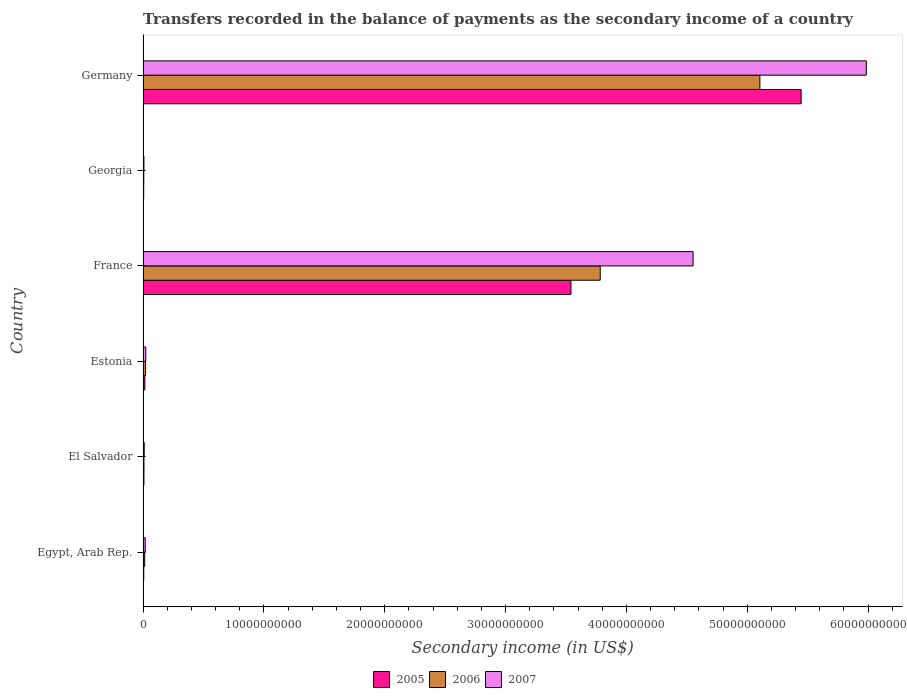How many groups of bars are there?
Offer a very short reply. 6. Are the number of bars per tick equal to the number of legend labels?
Your answer should be very brief. Yes. Are the number of bars on each tick of the Y-axis equal?
Keep it short and to the point. Yes. How many bars are there on the 5th tick from the top?
Provide a succinct answer. 3. What is the label of the 5th group of bars from the top?
Provide a succinct answer. El Salvador. In how many cases, is the number of bars for a given country not equal to the number of legend labels?
Your response must be concise. 0. What is the secondary income of in 2005 in Georgia?
Offer a terse response. 5.19e+07. Across all countries, what is the maximum secondary income of in 2006?
Your response must be concise. 5.10e+1. Across all countries, what is the minimum secondary income of in 2005?
Provide a succinct answer. 5.19e+07. In which country was the secondary income of in 2007 minimum?
Give a very brief answer. Georgia. What is the total secondary income of in 2007 in the graph?
Keep it short and to the point. 1.06e+11. What is the difference between the secondary income of in 2005 in El Salvador and that in France?
Offer a very short reply. -3.53e+1. What is the difference between the secondary income of in 2005 in El Salvador and the secondary income of in 2007 in Germany?
Ensure brevity in your answer.  -5.98e+1. What is the average secondary income of in 2006 per country?
Make the answer very short. 1.49e+1. What is the difference between the secondary income of in 2005 and secondary income of in 2006 in Egypt, Arab Rep.?
Provide a succinct answer. -7.78e+07. What is the ratio of the secondary income of in 2005 in El Salvador to that in Estonia?
Your answer should be very brief. 0.49. Is the secondary income of in 2007 in El Salvador less than that in Germany?
Your answer should be very brief. Yes. Is the difference between the secondary income of in 2005 in Egypt, Arab Rep. and El Salvador greater than the difference between the secondary income of in 2006 in Egypt, Arab Rep. and El Salvador?
Provide a short and direct response. No. What is the difference between the highest and the second highest secondary income of in 2006?
Your response must be concise. 1.32e+1. What is the difference between the highest and the lowest secondary income of in 2005?
Provide a short and direct response. 5.44e+1. In how many countries, is the secondary income of in 2005 greater than the average secondary income of in 2005 taken over all countries?
Your response must be concise. 2. Is the sum of the secondary income of in 2007 in Estonia and France greater than the maximum secondary income of in 2005 across all countries?
Provide a succinct answer. No. What does the 2nd bar from the bottom in France represents?
Offer a terse response. 2006. Are all the bars in the graph horizontal?
Offer a terse response. Yes. What is the difference between two consecutive major ticks on the X-axis?
Offer a terse response. 1.00e+1. Does the graph contain any zero values?
Ensure brevity in your answer.  No. Where does the legend appear in the graph?
Your answer should be very brief. Bottom center. What is the title of the graph?
Give a very brief answer. Transfers recorded in the balance of payments as the secondary income of a country. Does "1970" appear as one of the legend labels in the graph?
Ensure brevity in your answer.  No. What is the label or title of the X-axis?
Provide a short and direct response. Secondary income (in US$). What is the label or title of the Y-axis?
Your answer should be compact. Country. What is the Secondary income (in US$) of 2005 in Egypt, Arab Rep.?
Offer a very short reply. 5.73e+07. What is the Secondary income (in US$) in 2006 in Egypt, Arab Rep.?
Make the answer very short. 1.35e+08. What is the Secondary income (in US$) in 2007 in Egypt, Arab Rep.?
Offer a very short reply. 1.80e+08. What is the Secondary income (in US$) in 2005 in El Salvador?
Give a very brief answer. 7.14e+07. What is the Secondary income (in US$) in 2006 in El Salvador?
Keep it short and to the point. 7.68e+07. What is the Secondary income (in US$) of 2007 in El Salvador?
Ensure brevity in your answer.  9.57e+07. What is the Secondary income (in US$) of 2005 in Estonia?
Make the answer very short. 1.46e+08. What is the Secondary income (in US$) in 2006 in Estonia?
Give a very brief answer. 2.08e+08. What is the Secondary income (in US$) of 2007 in Estonia?
Give a very brief answer. 2.27e+08. What is the Secondary income (in US$) of 2005 in France?
Ensure brevity in your answer.  3.54e+1. What is the Secondary income (in US$) of 2006 in France?
Provide a succinct answer. 3.78e+1. What is the Secondary income (in US$) in 2007 in France?
Your answer should be very brief. 4.55e+1. What is the Secondary income (in US$) of 2005 in Georgia?
Give a very brief answer. 5.19e+07. What is the Secondary income (in US$) of 2006 in Georgia?
Provide a succinct answer. 5.94e+07. What is the Secondary income (in US$) of 2007 in Georgia?
Offer a terse response. 7.21e+07. What is the Secondary income (in US$) in 2005 in Germany?
Keep it short and to the point. 5.45e+1. What is the Secondary income (in US$) in 2006 in Germany?
Ensure brevity in your answer.  5.10e+1. What is the Secondary income (in US$) in 2007 in Germany?
Provide a succinct answer. 5.99e+1. Across all countries, what is the maximum Secondary income (in US$) in 2005?
Your answer should be very brief. 5.45e+1. Across all countries, what is the maximum Secondary income (in US$) in 2006?
Make the answer very short. 5.10e+1. Across all countries, what is the maximum Secondary income (in US$) in 2007?
Make the answer very short. 5.99e+1. Across all countries, what is the minimum Secondary income (in US$) in 2005?
Keep it short and to the point. 5.19e+07. Across all countries, what is the minimum Secondary income (in US$) in 2006?
Keep it short and to the point. 5.94e+07. Across all countries, what is the minimum Secondary income (in US$) of 2007?
Provide a succinct answer. 7.21e+07. What is the total Secondary income (in US$) in 2005 in the graph?
Keep it short and to the point. 9.02e+1. What is the total Secondary income (in US$) in 2006 in the graph?
Provide a short and direct response. 8.94e+1. What is the total Secondary income (in US$) in 2007 in the graph?
Provide a succinct answer. 1.06e+11. What is the difference between the Secondary income (in US$) in 2005 in Egypt, Arab Rep. and that in El Salvador?
Make the answer very short. -1.41e+07. What is the difference between the Secondary income (in US$) in 2006 in Egypt, Arab Rep. and that in El Salvador?
Ensure brevity in your answer.  5.83e+07. What is the difference between the Secondary income (in US$) in 2007 in Egypt, Arab Rep. and that in El Salvador?
Your answer should be compact. 8.42e+07. What is the difference between the Secondary income (in US$) of 2005 in Egypt, Arab Rep. and that in Estonia?
Give a very brief answer. -8.83e+07. What is the difference between the Secondary income (in US$) of 2006 in Egypt, Arab Rep. and that in Estonia?
Ensure brevity in your answer.  -7.26e+07. What is the difference between the Secondary income (in US$) of 2007 in Egypt, Arab Rep. and that in Estonia?
Make the answer very short. -4.70e+07. What is the difference between the Secondary income (in US$) in 2005 in Egypt, Arab Rep. and that in France?
Offer a terse response. -3.54e+1. What is the difference between the Secondary income (in US$) in 2006 in Egypt, Arab Rep. and that in France?
Your answer should be compact. -3.77e+1. What is the difference between the Secondary income (in US$) of 2007 in Egypt, Arab Rep. and that in France?
Offer a terse response. -4.53e+1. What is the difference between the Secondary income (in US$) of 2005 in Egypt, Arab Rep. and that in Georgia?
Your answer should be very brief. 5.35e+06. What is the difference between the Secondary income (in US$) of 2006 in Egypt, Arab Rep. and that in Georgia?
Your response must be concise. 7.57e+07. What is the difference between the Secondary income (in US$) in 2007 in Egypt, Arab Rep. and that in Georgia?
Your response must be concise. 1.08e+08. What is the difference between the Secondary income (in US$) of 2005 in Egypt, Arab Rep. and that in Germany?
Offer a very short reply. -5.44e+1. What is the difference between the Secondary income (in US$) of 2006 in Egypt, Arab Rep. and that in Germany?
Ensure brevity in your answer.  -5.09e+1. What is the difference between the Secondary income (in US$) in 2007 in Egypt, Arab Rep. and that in Germany?
Ensure brevity in your answer.  -5.97e+1. What is the difference between the Secondary income (in US$) of 2005 in El Salvador and that in Estonia?
Your answer should be compact. -7.42e+07. What is the difference between the Secondary income (in US$) in 2006 in El Salvador and that in Estonia?
Your answer should be very brief. -1.31e+08. What is the difference between the Secondary income (in US$) in 2007 in El Salvador and that in Estonia?
Your answer should be very brief. -1.31e+08. What is the difference between the Secondary income (in US$) in 2005 in El Salvador and that in France?
Give a very brief answer. -3.53e+1. What is the difference between the Secondary income (in US$) in 2006 in El Salvador and that in France?
Your response must be concise. -3.78e+1. What is the difference between the Secondary income (in US$) in 2007 in El Salvador and that in France?
Your answer should be very brief. -4.54e+1. What is the difference between the Secondary income (in US$) of 2005 in El Salvador and that in Georgia?
Keep it short and to the point. 1.95e+07. What is the difference between the Secondary income (in US$) of 2006 in El Salvador and that in Georgia?
Ensure brevity in your answer.  1.74e+07. What is the difference between the Secondary income (in US$) in 2007 in El Salvador and that in Georgia?
Your answer should be very brief. 2.37e+07. What is the difference between the Secondary income (in US$) of 2005 in El Salvador and that in Germany?
Offer a terse response. -5.44e+1. What is the difference between the Secondary income (in US$) in 2006 in El Salvador and that in Germany?
Offer a terse response. -5.10e+1. What is the difference between the Secondary income (in US$) of 2007 in El Salvador and that in Germany?
Offer a very short reply. -5.98e+1. What is the difference between the Secondary income (in US$) in 2005 in Estonia and that in France?
Your answer should be compact. -3.53e+1. What is the difference between the Secondary income (in US$) in 2006 in Estonia and that in France?
Make the answer very short. -3.76e+1. What is the difference between the Secondary income (in US$) of 2007 in Estonia and that in France?
Your response must be concise. -4.53e+1. What is the difference between the Secondary income (in US$) of 2005 in Estonia and that in Georgia?
Give a very brief answer. 9.36e+07. What is the difference between the Secondary income (in US$) of 2006 in Estonia and that in Georgia?
Your answer should be compact. 1.48e+08. What is the difference between the Secondary income (in US$) of 2007 in Estonia and that in Georgia?
Provide a short and direct response. 1.55e+08. What is the difference between the Secondary income (in US$) in 2005 in Estonia and that in Germany?
Offer a terse response. -5.43e+1. What is the difference between the Secondary income (in US$) of 2006 in Estonia and that in Germany?
Keep it short and to the point. -5.08e+1. What is the difference between the Secondary income (in US$) in 2007 in Estonia and that in Germany?
Make the answer very short. -5.96e+1. What is the difference between the Secondary income (in US$) of 2005 in France and that in Georgia?
Keep it short and to the point. 3.54e+1. What is the difference between the Secondary income (in US$) of 2006 in France and that in Georgia?
Your answer should be compact. 3.78e+1. What is the difference between the Secondary income (in US$) in 2007 in France and that in Georgia?
Your response must be concise. 4.54e+1. What is the difference between the Secondary income (in US$) of 2005 in France and that in Germany?
Make the answer very short. -1.91e+1. What is the difference between the Secondary income (in US$) in 2006 in France and that in Germany?
Ensure brevity in your answer.  -1.32e+1. What is the difference between the Secondary income (in US$) in 2007 in France and that in Germany?
Keep it short and to the point. -1.43e+1. What is the difference between the Secondary income (in US$) in 2005 in Georgia and that in Germany?
Keep it short and to the point. -5.44e+1. What is the difference between the Secondary income (in US$) in 2006 in Georgia and that in Germany?
Keep it short and to the point. -5.10e+1. What is the difference between the Secondary income (in US$) in 2007 in Georgia and that in Germany?
Your answer should be very brief. -5.98e+1. What is the difference between the Secondary income (in US$) of 2005 in Egypt, Arab Rep. and the Secondary income (in US$) of 2006 in El Salvador?
Keep it short and to the point. -1.95e+07. What is the difference between the Secondary income (in US$) in 2005 in Egypt, Arab Rep. and the Secondary income (in US$) in 2007 in El Salvador?
Your answer should be compact. -3.84e+07. What is the difference between the Secondary income (in US$) of 2006 in Egypt, Arab Rep. and the Secondary income (in US$) of 2007 in El Salvador?
Provide a succinct answer. 3.94e+07. What is the difference between the Secondary income (in US$) in 2005 in Egypt, Arab Rep. and the Secondary income (in US$) in 2006 in Estonia?
Your answer should be compact. -1.50e+08. What is the difference between the Secondary income (in US$) of 2005 in Egypt, Arab Rep. and the Secondary income (in US$) of 2007 in Estonia?
Provide a short and direct response. -1.70e+08. What is the difference between the Secondary income (in US$) of 2006 in Egypt, Arab Rep. and the Secondary income (in US$) of 2007 in Estonia?
Provide a succinct answer. -9.18e+07. What is the difference between the Secondary income (in US$) of 2005 in Egypt, Arab Rep. and the Secondary income (in US$) of 2006 in France?
Make the answer very short. -3.78e+1. What is the difference between the Secondary income (in US$) in 2005 in Egypt, Arab Rep. and the Secondary income (in US$) in 2007 in France?
Offer a terse response. -4.55e+1. What is the difference between the Secondary income (in US$) in 2006 in Egypt, Arab Rep. and the Secondary income (in US$) in 2007 in France?
Offer a terse response. -4.54e+1. What is the difference between the Secondary income (in US$) in 2005 in Egypt, Arab Rep. and the Secondary income (in US$) in 2006 in Georgia?
Provide a succinct answer. -2.07e+06. What is the difference between the Secondary income (in US$) in 2005 in Egypt, Arab Rep. and the Secondary income (in US$) in 2007 in Georgia?
Provide a short and direct response. -1.48e+07. What is the difference between the Secondary income (in US$) of 2006 in Egypt, Arab Rep. and the Secondary income (in US$) of 2007 in Georgia?
Your answer should be compact. 6.30e+07. What is the difference between the Secondary income (in US$) in 2005 in Egypt, Arab Rep. and the Secondary income (in US$) in 2006 in Germany?
Make the answer very short. -5.10e+1. What is the difference between the Secondary income (in US$) of 2005 in Egypt, Arab Rep. and the Secondary income (in US$) of 2007 in Germany?
Give a very brief answer. -5.98e+1. What is the difference between the Secondary income (in US$) in 2006 in Egypt, Arab Rep. and the Secondary income (in US$) in 2007 in Germany?
Keep it short and to the point. -5.97e+1. What is the difference between the Secondary income (in US$) in 2005 in El Salvador and the Secondary income (in US$) in 2006 in Estonia?
Offer a very short reply. -1.36e+08. What is the difference between the Secondary income (in US$) in 2005 in El Salvador and the Secondary income (in US$) in 2007 in Estonia?
Your answer should be very brief. -1.55e+08. What is the difference between the Secondary income (in US$) in 2006 in El Salvador and the Secondary income (in US$) in 2007 in Estonia?
Your answer should be compact. -1.50e+08. What is the difference between the Secondary income (in US$) in 2005 in El Salvador and the Secondary income (in US$) in 2006 in France?
Your answer should be very brief. -3.78e+1. What is the difference between the Secondary income (in US$) of 2005 in El Salvador and the Secondary income (in US$) of 2007 in France?
Provide a short and direct response. -4.54e+1. What is the difference between the Secondary income (in US$) of 2006 in El Salvador and the Secondary income (in US$) of 2007 in France?
Provide a succinct answer. -4.54e+1. What is the difference between the Secondary income (in US$) in 2005 in El Salvador and the Secondary income (in US$) in 2006 in Georgia?
Ensure brevity in your answer.  1.20e+07. What is the difference between the Secondary income (in US$) of 2005 in El Salvador and the Secondary income (in US$) of 2007 in Georgia?
Give a very brief answer. -6.62e+05. What is the difference between the Secondary income (in US$) in 2006 in El Salvador and the Secondary income (in US$) in 2007 in Georgia?
Keep it short and to the point. 4.72e+06. What is the difference between the Secondary income (in US$) of 2005 in El Salvador and the Secondary income (in US$) of 2006 in Germany?
Your answer should be compact. -5.10e+1. What is the difference between the Secondary income (in US$) in 2005 in El Salvador and the Secondary income (in US$) in 2007 in Germany?
Keep it short and to the point. -5.98e+1. What is the difference between the Secondary income (in US$) of 2006 in El Salvador and the Secondary income (in US$) of 2007 in Germany?
Make the answer very short. -5.98e+1. What is the difference between the Secondary income (in US$) in 2005 in Estonia and the Secondary income (in US$) in 2006 in France?
Ensure brevity in your answer.  -3.77e+1. What is the difference between the Secondary income (in US$) in 2005 in Estonia and the Secondary income (in US$) in 2007 in France?
Provide a short and direct response. -4.54e+1. What is the difference between the Secondary income (in US$) of 2006 in Estonia and the Secondary income (in US$) of 2007 in France?
Give a very brief answer. -4.53e+1. What is the difference between the Secondary income (in US$) in 2005 in Estonia and the Secondary income (in US$) in 2006 in Georgia?
Give a very brief answer. 8.62e+07. What is the difference between the Secondary income (in US$) of 2005 in Estonia and the Secondary income (in US$) of 2007 in Georgia?
Provide a succinct answer. 7.35e+07. What is the difference between the Secondary income (in US$) in 2006 in Estonia and the Secondary income (in US$) in 2007 in Georgia?
Your answer should be compact. 1.36e+08. What is the difference between the Secondary income (in US$) in 2005 in Estonia and the Secondary income (in US$) in 2006 in Germany?
Make the answer very short. -5.09e+1. What is the difference between the Secondary income (in US$) in 2005 in Estonia and the Secondary income (in US$) in 2007 in Germany?
Offer a very short reply. -5.97e+1. What is the difference between the Secondary income (in US$) in 2006 in Estonia and the Secondary income (in US$) in 2007 in Germany?
Offer a very short reply. -5.96e+1. What is the difference between the Secondary income (in US$) of 2005 in France and the Secondary income (in US$) of 2006 in Georgia?
Offer a very short reply. 3.54e+1. What is the difference between the Secondary income (in US$) of 2005 in France and the Secondary income (in US$) of 2007 in Georgia?
Your answer should be very brief. 3.53e+1. What is the difference between the Secondary income (in US$) in 2006 in France and the Secondary income (in US$) in 2007 in Georgia?
Your response must be concise. 3.78e+1. What is the difference between the Secondary income (in US$) in 2005 in France and the Secondary income (in US$) in 2006 in Germany?
Your response must be concise. -1.56e+1. What is the difference between the Secondary income (in US$) in 2005 in France and the Secondary income (in US$) in 2007 in Germany?
Provide a succinct answer. -2.44e+1. What is the difference between the Secondary income (in US$) in 2006 in France and the Secondary income (in US$) in 2007 in Germany?
Ensure brevity in your answer.  -2.20e+1. What is the difference between the Secondary income (in US$) in 2005 in Georgia and the Secondary income (in US$) in 2006 in Germany?
Give a very brief answer. -5.10e+1. What is the difference between the Secondary income (in US$) of 2005 in Georgia and the Secondary income (in US$) of 2007 in Germany?
Make the answer very short. -5.98e+1. What is the difference between the Secondary income (in US$) of 2006 in Georgia and the Secondary income (in US$) of 2007 in Germany?
Provide a short and direct response. -5.98e+1. What is the average Secondary income (in US$) of 2005 per country?
Your response must be concise. 1.50e+1. What is the average Secondary income (in US$) of 2006 per country?
Keep it short and to the point. 1.49e+1. What is the average Secondary income (in US$) in 2007 per country?
Keep it short and to the point. 1.77e+1. What is the difference between the Secondary income (in US$) of 2005 and Secondary income (in US$) of 2006 in Egypt, Arab Rep.?
Your answer should be compact. -7.78e+07. What is the difference between the Secondary income (in US$) of 2005 and Secondary income (in US$) of 2007 in Egypt, Arab Rep.?
Keep it short and to the point. -1.23e+08. What is the difference between the Secondary income (in US$) in 2006 and Secondary income (in US$) in 2007 in Egypt, Arab Rep.?
Make the answer very short. -4.48e+07. What is the difference between the Secondary income (in US$) of 2005 and Secondary income (in US$) of 2006 in El Salvador?
Your answer should be very brief. -5.38e+06. What is the difference between the Secondary income (in US$) in 2005 and Secondary income (in US$) in 2007 in El Salvador?
Offer a terse response. -2.43e+07. What is the difference between the Secondary income (in US$) in 2006 and Secondary income (in US$) in 2007 in El Salvador?
Your answer should be very brief. -1.90e+07. What is the difference between the Secondary income (in US$) in 2005 and Secondary income (in US$) in 2006 in Estonia?
Provide a succinct answer. -6.21e+07. What is the difference between the Secondary income (in US$) of 2005 and Secondary income (in US$) of 2007 in Estonia?
Your answer should be compact. -8.13e+07. What is the difference between the Secondary income (in US$) of 2006 and Secondary income (in US$) of 2007 in Estonia?
Keep it short and to the point. -1.92e+07. What is the difference between the Secondary income (in US$) in 2005 and Secondary income (in US$) in 2006 in France?
Provide a succinct answer. -2.42e+09. What is the difference between the Secondary income (in US$) of 2005 and Secondary income (in US$) of 2007 in France?
Provide a succinct answer. -1.01e+1. What is the difference between the Secondary income (in US$) in 2006 and Secondary income (in US$) in 2007 in France?
Keep it short and to the point. -7.69e+09. What is the difference between the Secondary income (in US$) in 2005 and Secondary income (in US$) in 2006 in Georgia?
Offer a terse response. -7.43e+06. What is the difference between the Secondary income (in US$) of 2005 and Secondary income (in US$) of 2007 in Georgia?
Keep it short and to the point. -2.01e+07. What is the difference between the Secondary income (in US$) of 2006 and Secondary income (in US$) of 2007 in Georgia?
Offer a terse response. -1.27e+07. What is the difference between the Secondary income (in US$) of 2005 and Secondary income (in US$) of 2006 in Germany?
Your response must be concise. 3.42e+09. What is the difference between the Secondary income (in US$) in 2005 and Secondary income (in US$) in 2007 in Germany?
Your answer should be very brief. -5.39e+09. What is the difference between the Secondary income (in US$) of 2006 and Secondary income (in US$) of 2007 in Germany?
Offer a very short reply. -8.81e+09. What is the ratio of the Secondary income (in US$) of 2005 in Egypt, Arab Rep. to that in El Salvador?
Offer a terse response. 0.8. What is the ratio of the Secondary income (in US$) of 2006 in Egypt, Arab Rep. to that in El Salvador?
Your response must be concise. 1.76. What is the ratio of the Secondary income (in US$) of 2007 in Egypt, Arab Rep. to that in El Salvador?
Your response must be concise. 1.88. What is the ratio of the Secondary income (in US$) in 2005 in Egypt, Arab Rep. to that in Estonia?
Ensure brevity in your answer.  0.39. What is the ratio of the Secondary income (in US$) in 2006 in Egypt, Arab Rep. to that in Estonia?
Offer a terse response. 0.65. What is the ratio of the Secondary income (in US$) of 2007 in Egypt, Arab Rep. to that in Estonia?
Keep it short and to the point. 0.79. What is the ratio of the Secondary income (in US$) of 2005 in Egypt, Arab Rep. to that in France?
Offer a very short reply. 0. What is the ratio of the Secondary income (in US$) in 2006 in Egypt, Arab Rep. to that in France?
Provide a succinct answer. 0. What is the ratio of the Secondary income (in US$) in 2007 in Egypt, Arab Rep. to that in France?
Offer a terse response. 0. What is the ratio of the Secondary income (in US$) of 2005 in Egypt, Arab Rep. to that in Georgia?
Provide a short and direct response. 1.1. What is the ratio of the Secondary income (in US$) of 2006 in Egypt, Arab Rep. to that in Georgia?
Keep it short and to the point. 2.28. What is the ratio of the Secondary income (in US$) in 2007 in Egypt, Arab Rep. to that in Georgia?
Provide a short and direct response. 2.5. What is the ratio of the Secondary income (in US$) in 2005 in Egypt, Arab Rep. to that in Germany?
Give a very brief answer. 0. What is the ratio of the Secondary income (in US$) in 2006 in Egypt, Arab Rep. to that in Germany?
Offer a very short reply. 0. What is the ratio of the Secondary income (in US$) in 2007 in Egypt, Arab Rep. to that in Germany?
Provide a short and direct response. 0. What is the ratio of the Secondary income (in US$) of 2005 in El Salvador to that in Estonia?
Your response must be concise. 0.49. What is the ratio of the Secondary income (in US$) of 2006 in El Salvador to that in Estonia?
Give a very brief answer. 0.37. What is the ratio of the Secondary income (in US$) of 2007 in El Salvador to that in Estonia?
Keep it short and to the point. 0.42. What is the ratio of the Secondary income (in US$) of 2005 in El Salvador to that in France?
Provide a succinct answer. 0. What is the ratio of the Secondary income (in US$) of 2006 in El Salvador to that in France?
Offer a very short reply. 0. What is the ratio of the Secondary income (in US$) of 2007 in El Salvador to that in France?
Offer a terse response. 0. What is the ratio of the Secondary income (in US$) of 2005 in El Salvador to that in Georgia?
Provide a short and direct response. 1.37. What is the ratio of the Secondary income (in US$) of 2006 in El Salvador to that in Georgia?
Your response must be concise. 1.29. What is the ratio of the Secondary income (in US$) of 2007 in El Salvador to that in Georgia?
Your answer should be very brief. 1.33. What is the ratio of the Secondary income (in US$) of 2005 in El Salvador to that in Germany?
Give a very brief answer. 0. What is the ratio of the Secondary income (in US$) of 2006 in El Salvador to that in Germany?
Provide a short and direct response. 0. What is the ratio of the Secondary income (in US$) in 2007 in El Salvador to that in Germany?
Ensure brevity in your answer.  0. What is the ratio of the Secondary income (in US$) in 2005 in Estonia to that in France?
Provide a succinct answer. 0. What is the ratio of the Secondary income (in US$) in 2006 in Estonia to that in France?
Your response must be concise. 0.01. What is the ratio of the Secondary income (in US$) of 2007 in Estonia to that in France?
Your answer should be very brief. 0.01. What is the ratio of the Secondary income (in US$) of 2005 in Estonia to that in Georgia?
Keep it short and to the point. 2.8. What is the ratio of the Secondary income (in US$) of 2006 in Estonia to that in Georgia?
Provide a short and direct response. 3.5. What is the ratio of the Secondary income (in US$) of 2007 in Estonia to that in Georgia?
Ensure brevity in your answer.  3.15. What is the ratio of the Secondary income (in US$) in 2005 in Estonia to that in Germany?
Your answer should be very brief. 0. What is the ratio of the Secondary income (in US$) in 2006 in Estonia to that in Germany?
Offer a very short reply. 0. What is the ratio of the Secondary income (in US$) in 2007 in Estonia to that in Germany?
Keep it short and to the point. 0. What is the ratio of the Secondary income (in US$) of 2005 in France to that in Georgia?
Offer a terse response. 681.68. What is the ratio of the Secondary income (in US$) in 2006 in France to that in Georgia?
Give a very brief answer. 637.24. What is the ratio of the Secondary income (in US$) in 2007 in France to that in Georgia?
Your answer should be very brief. 631.67. What is the ratio of the Secondary income (in US$) of 2005 in France to that in Germany?
Offer a very short reply. 0.65. What is the ratio of the Secondary income (in US$) in 2006 in France to that in Germany?
Your response must be concise. 0.74. What is the ratio of the Secondary income (in US$) of 2007 in France to that in Germany?
Provide a short and direct response. 0.76. What is the ratio of the Secondary income (in US$) in 2005 in Georgia to that in Germany?
Your answer should be compact. 0. What is the ratio of the Secondary income (in US$) of 2006 in Georgia to that in Germany?
Your response must be concise. 0. What is the ratio of the Secondary income (in US$) in 2007 in Georgia to that in Germany?
Provide a succinct answer. 0. What is the difference between the highest and the second highest Secondary income (in US$) of 2005?
Keep it short and to the point. 1.91e+1. What is the difference between the highest and the second highest Secondary income (in US$) of 2006?
Offer a terse response. 1.32e+1. What is the difference between the highest and the second highest Secondary income (in US$) of 2007?
Ensure brevity in your answer.  1.43e+1. What is the difference between the highest and the lowest Secondary income (in US$) in 2005?
Make the answer very short. 5.44e+1. What is the difference between the highest and the lowest Secondary income (in US$) in 2006?
Make the answer very short. 5.10e+1. What is the difference between the highest and the lowest Secondary income (in US$) of 2007?
Offer a very short reply. 5.98e+1. 